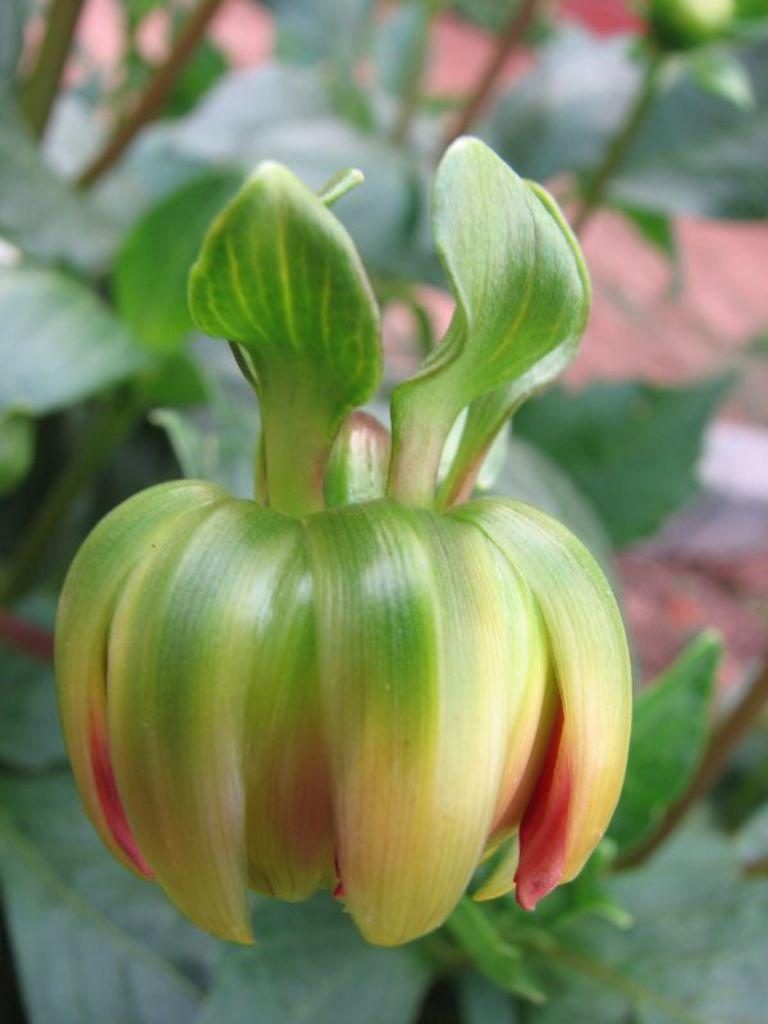In one or two sentences, can you explain what this image depicts? Here we can see a flower and leaves. There is a blur background. 